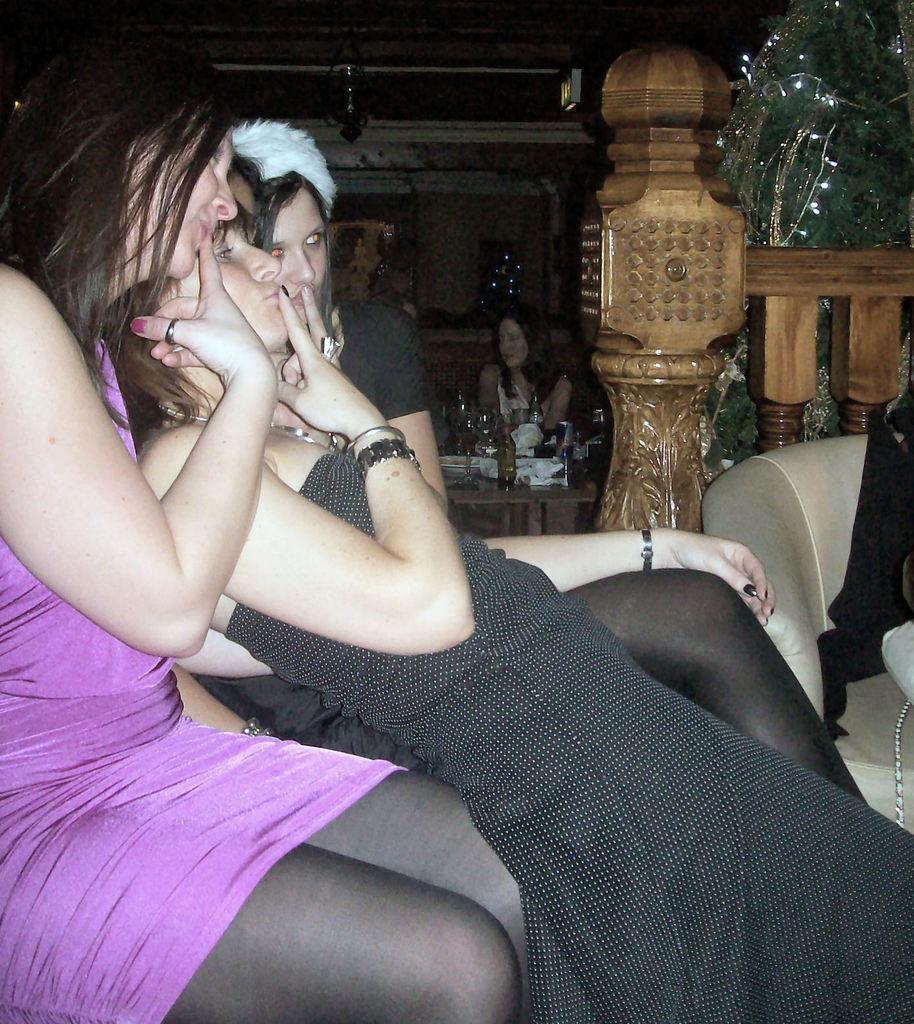Can you describe this image briefly? In this image I can see three women wearing black and pink colored dresses are sitting on a couch. In the background I can see another couch, few persons, a table with few objects on it, the brown colored wooden object, a christmas tree with few lights to it and few other objects. 